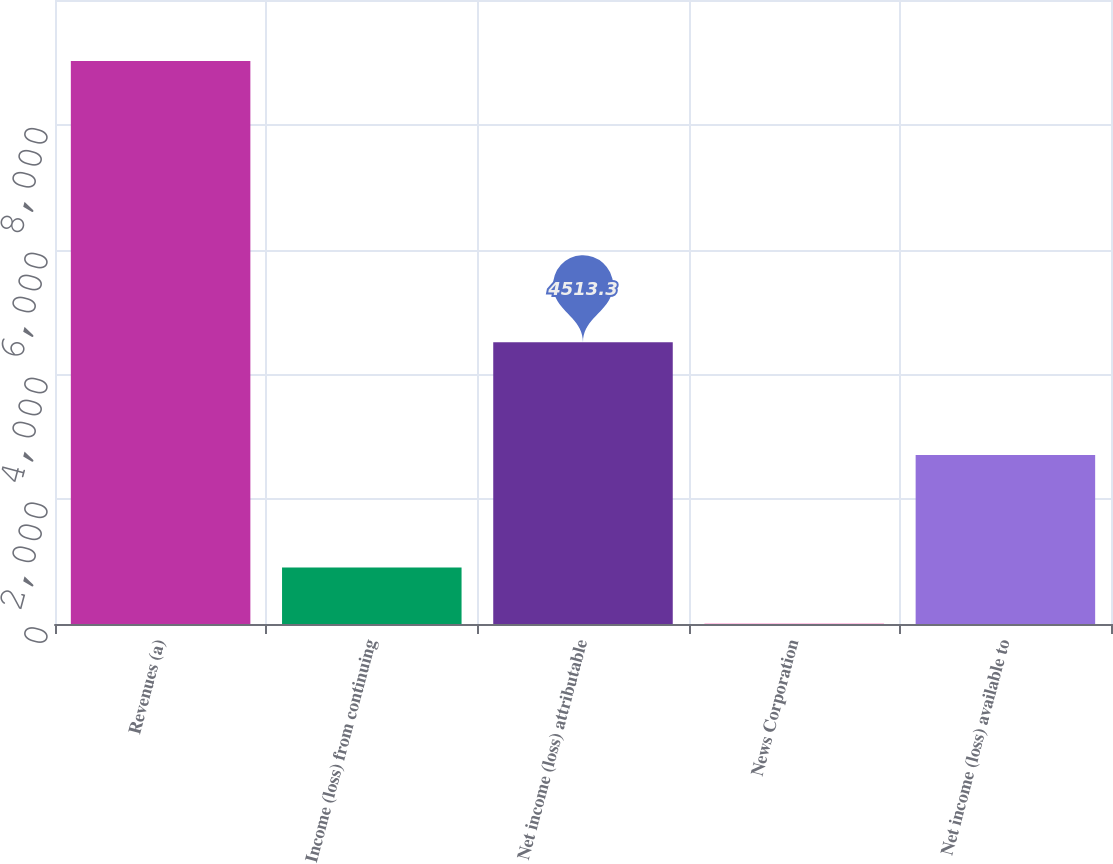<chart> <loc_0><loc_0><loc_500><loc_500><bar_chart><fcel>Revenues (a)<fcel>Income (loss) from continuing<fcel>Net income (loss) attributable<fcel>News Corporation<fcel>Net income (loss) available to<nl><fcel>9024<fcel>904.74<fcel>4513.3<fcel>2.6<fcel>2709.02<nl></chart> 